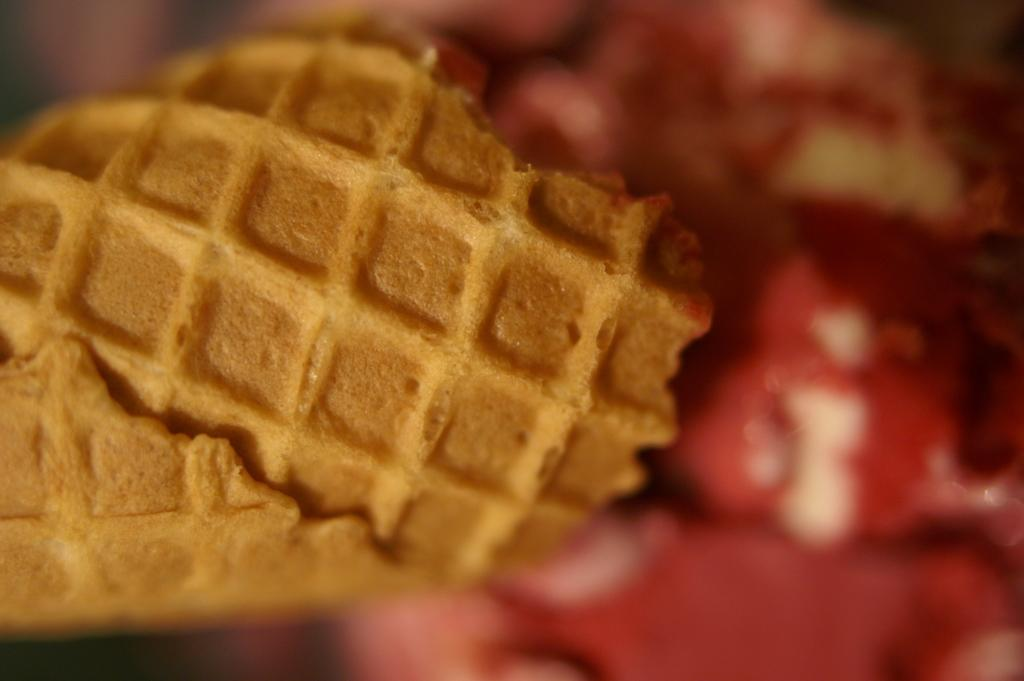What type of food is visible in the image? There is a waffle in the image. What type of trail can be seen in the image? There is no trail present in the image; it only features a waffle. What type of linen is used to cover the waffle in the image? There is no linen present in the image, as it only features a waffle. 